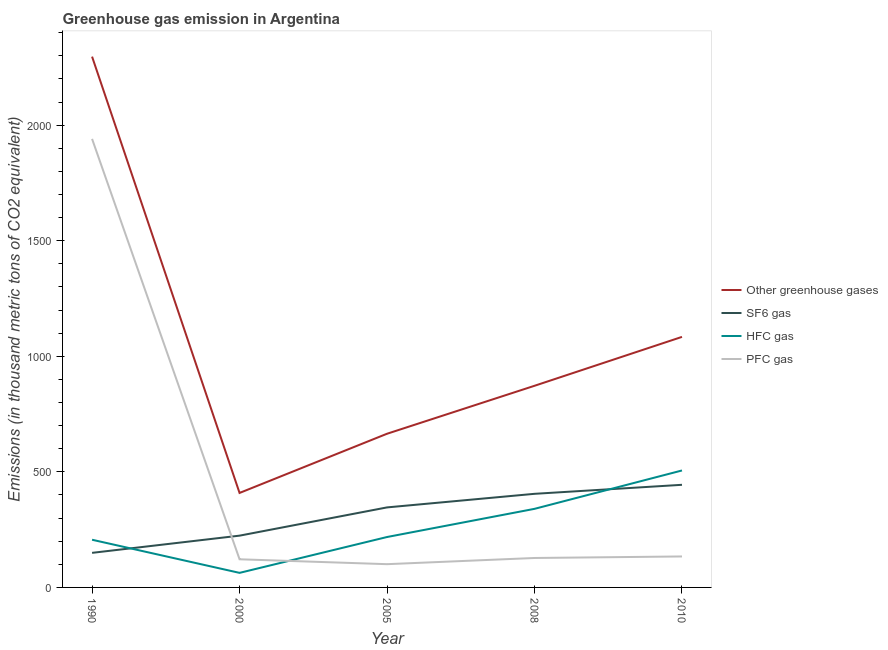How many different coloured lines are there?
Offer a very short reply. 4. What is the emission of hfc gas in 2005?
Make the answer very short. 218.1. Across all years, what is the maximum emission of sf6 gas?
Your response must be concise. 444. Across all years, what is the minimum emission of sf6 gas?
Your answer should be very brief. 149.6. What is the total emission of pfc gas in the graph?
Keep it short and to the point. 2424.4. What is the difference between the emission of sf6 gas in 1990 and that in 2008?
Ensure brevity in your answer.  -255.4. What is the difference between the emission of hfc gas in 2005 and the emission of sf6 gas in 2008?
Offer a terse response. -186.9. What is the average emission of hfc gas per year?
Ensure brevity in your answer.  266.68. In the year 2008, what is the difference between the emission of greenhouse gases and emission of hfc gas?
Your answer should be very brief. 532.4. In how many years, is the emission of hfc gas greater than 1200 thousand metric tons?
Your answer should be compact. 0. What is the ratio of the emission of hfc gas in 2000 to that in 2008?
Offer a very short reply. 0.19. Is the difference between the emission of sf6 gas in 1990 and 2005 greater than the difference between the emission of greenhouse gases in 1990 and 2005?
Your answer should be very brief. No. What is the difference between the highest and the second highest emission of pfc gas?
Give a very brief answer. 1806.6. What is the difference between the highest and the lowest emission of sf6 gas?
Provide a succinct answer. 294.4. In how many years, is the emission of pfc gas greater than the average emission of pfc gas taken over all years?
Your answer should be compact. 1. Is the sum of the emission of hfc gas in 2005 and 2010 greater than the maximum emission of pfc gas across all years?
Offer a terse response. No. Is it the case that in every year, the sum of the emission of greenhouse gases and emission of sf6 gas is greater than the emission of hfc gas?
Offer a terse response. Yes. Does the emission of pfc gas monotonically increase over the years?
Provide a succinct answer. No. Is the emission of greenhouse gases strictly less than the emission of hfc gas over the years?
Make the answer very short. No. How many years are there in the graph?
Your response must be concise. 5. What is the difference between two consecutive major ticks on the Y-axis?
Your response must be concise. 500. What is the title of the graph?
Ensure brevity in your answer.  Greenhouse gas emission in Argentina. Does "Secondary vocational" appear as one of the legend labels in the graph?
Keep it short and to the point. No. What is the label or title of the X-axis?
Your answer should be compact. Year. What is the label or title of the Y-axis?
Offer a terse response. Emissions (in thousand metric tons of CO2 equivalent). What is the Emissions (in thousand metric tons of CO2 equivalent) in Other greenhouse gases in 1990?
Make the answer very short. 2296.5. What is the Emissions (in thousand metric tons of CO2 equivalent) in SF6 gas in 1990?
Provide a succinct answer. 149.6. What is the Emissions (in thousand metric tons of CO2 equivalent) of HFC gas in 1990?
Your response must be concise. 206.3. What is the Emissions (in thousand metric tons of CO2 equivalent) in PFC gas in 1990?
Your answer should be very brief. 1940.6. What is the Emissions (in thousand metric tons of CO2 equivalent) of Other greenhouse gases in 2000?
Give a very brief answer. 408.8. What is the Emissions (in thousand metric tons of CO2 equivalent) of SF6 gas in 2000?
Your response must be concise. 224. What is the Emissions (in thousand metric tons of CO2 equivalent) of PFC gas in 2000?
Your answer should be very brief. 121.8. What is the Emissions (in thousand metric tons of CO2 equivalent) in Other greenhouse gases in 2005?
Your answer should be very brief. 664.9. What is the Emissions (in thousand metric tons of CO2 equivalent) of SF6 gas in 2005?
Keep it short and to the point. 346.2. What is the Emissions (in thousand metric tons of CO2 equivalent) of HFC gas in 2005?
Offer a terse response. 218.1. What is the Emissions (in thousand metric tons of CO2 equivalent) of PFC gas in 2005?
Offer a terse response. 100.6. What is the Emissions (in thousand metric tons of CO2 equivalent) in Other greenhouse gases in 2008?
Provide a short and direct response. 872.4. What is the Emissions (in thousand metric tons of CO2 equivalent) of SF6 gas in 2008?
Your answer should be compact. 405. What is the Emissions (in thousand metric tons of CO2 equivalent) in HFC gas in 2008?
Make the answer very short. 340. What is the Emissions (in thousand metric tons of CO2 equivalent) of PFC gas in 2008?
Your answer should be very brief. 127.4. What is the Emissions (in thousand metric tons of CO2 equivalent) of Other greenhouse gases in 2010?
Offer a terse response. 1084. What is the Emissions (in thousand metric tons of CO2 equivalent) of SF6 gas in 2010?
Offer a terse response. 444. What is the Emissions (in thousand metric tons of CO2 equivalent) of HFC gas in 2010?
Offer a very short reply. 506. What is the Emissions (in thousand metric tons of CO2 equivalent) in PFC gas in 2010?
Offer a terse response. 134. Across all years, what is the maximum Emissions (in thousand metric tons of CO2 equivalent) in Other greenhouse gases?
Offer a very short reply. 2296.5. Across all years, what is the maximum Emissions (in thousand metric tons of CO2 equivalent) in SF6 gas?
Make the answer very short. 444. Across all years, what is the maximum Emissions (in thousand metric tons of CO2 equivalent) in HFC gas?
Offer a terse response. 506. Across all years, what is the maximum Emissions (in thousand metric tons of CO2 equivalent) of PFC gas?
Your response must be concise. 1940.6. Across all years, what is the minimum Emissions (in thousand metric tons of CO2 equivalent) of Other greenhouse gases?
Ensure brevity in your answer.  408.8. Across all years, what is the minimum Emissions (in thousand metric tons of CO2 equivalent) of SF6 gas?
Keep it short and to the point. 149.6. Across all years, what is the minimum Emissions (in thousand metric tons of CO2 equivalent) in HFC gas?
Offer a terse response. 63. Across all years, what is the minimum Emissions (in thousand metric tons of CO2 equivalent) of PFC gas?
Provide a succinct answer. 100.6. What is the total Emissions (in thousand metric tons of CO2 equivalent) of Other greenhouse gases in the graph?
Offer a very short reply. 5326.6. What is the total Emissions (in thousand metric tons of CO2 equivalent) of SF6 gas in the graph?
Make the answer very short. 1568.8. What is the total Emissions (in thousand metric tons of CO2 equivalent) in HFC gas in the graph?
Your answer should be compact. 1333.4. What is the total Emissions (in thousand metric tons of CO2 equivalent) in PFC gas in the graph?
Your response must be concise. 2424.4. What is the difference between the Emissions (in thousand metric tons of CO2 equivalent) of Other greenhouse gases in 1990 and that in 2000?
Offer a terse response. 1887.7. What is the difference between the Emissions (in thousand metric tons of CO2 equivalent) of SF6 gas in 1990 and that in 2000?
Your answer should be very brief. -74.4. What is the difference between the Emissions (in thousand metric tons of CO2 equivalent) of HFC gas in 1990 and that in 2000?
Offer a terse response. 143.3. What is the difference between the Emissions (in thousand metric tons of CO2 equivalent) in PFC gas in 1990 and that in 2000?
Make the answer very short. 1818.8. What is the difference between the Emissions (in thousand metric tons of CO2 equivalent) in Other greenhouse gases in 1990 and that in 2005?
Ensure brevity in your answer.  1631.6. What is the difference between the Emissions (in thousand metric tons of CO2 equivalent) of SF6 gas in 1990 and that in 2005?
Provide a succinct answer. -196.6. What is the difference between the Emissions (in thousand metric tons of CO2 equivalent) in HFC gas in 1990 and that in 2005?
Make the answer very short. -11.8. What is the difference between the Emissions (in thousand metric tons of CO2 equivalent) in PFC gas in 1990 and that in 2005?
Keep it short and to the point. 1840. What is the difference between the Emissions (in thousand metric tons of CO2 equivalent) in Other greenhouse gases in 1990 and that in 2008?
Your response must be concise. 1424.1. What is the difference between the Emissions (in thousand metric tons of CO2 equivalent) in SF6 gas in 1990 and that in 2008?
Provide a short and direct response. -255.4. What is the difference between the Emissions (in thousand metric tons of CO2 equivalent) in HFC gas in 1990 and that in 2008?
Give a very brief answer. -133.7. What is the difference between the Emissions (in thousand metric tons of CO2 equivalent) in PFC gas in 1990 and that in 2008?
Your answer should be very brief. 1813.2. What is the difference between the Emissions (in thousand metric tons of CO2 equivalent) of Other greenhouse gases in 1990 and that in 2010?
Keep it short and to the point. 1212.5. What is the difference between the Emissions (in thousand metric tons of CO2 equivalent) of SF6 gas in 1990 and that in 2010?
Make the answer very short. -294.4. What is the difference between the Emissions (in thousand metric tons of CO2 equivalent) in HFC gas in 1990 and that in 2010?
Provide a short and direct response. -299.7. What is the difference between the Emissions (in thousand metric tons of CO2 equivalent) of PFC gas in 1990 and that in 2010?
Keep it short and to the point. 1806.6. What is the difference between the Emissions (in thousand metric tons of CO2 equivalent) in Other greenhouse gases in 2000 and that in 2005?
Keep it short and to the point. -256.1. What is the difference between the Emissions (in thousand metric tons of CO2 equivalent) of SF6 gas in 2000 and that in 2005?
Your answer should be very brief. -122.2. What is the difference between the Emissions (in thousand metric tons of CO2 equivalent) of HFC gas in 2000 and that in 2005?
Ensure brevity in your answer.  -155.1. What is the difference between the Emissions (in thousand metric tons of CO2 equivalent) in PFC gas in 2000 and that in 2005?
Provide a short and direct response. 21.2. What is the difference between the Emissions (in thousand metric tons of CO2 equivalent) in Other greenhouse gases in 2000 and that in 2008?
Give a very brief answer. -463.6. What is the difference between the Emissions (in thousand metric tons of CO2 equivalent) of SF6 gas in 2000 and that in 2008?
Offer a terse response. -181. What is the difference between the Emissions (in thousand metric tons of CO2 equivalent) in HFC gas in 2000 and that in 2008?
Offer a very short reply. -277. What is the difference between the Emissions (in thousand metric tons of CO2 equivalent) in PFC gas in 2000 and that in 2008?
Provide a short and direct response. -5.6. What is the difference between the Emissions (in thousand metric tons of CO2 equivalent) in Other greenhouse gases in 2000 and that in 2010?
Your answer should be very brief. -675.2. What is the difference between the Emissions (in thousand metric tons of CO2 equivalent) in SF6 gas in 2000 and that in 2010?
Offer a very short reply. -220. What is the difference between the Emissions (in thousand metric tons of CO2 equivalent) in HFC gas in 2000 and that in 2010?
Offer a terse response. -443. What is the difference between the Emissions (in thousand metric tons of CO2 equivalent) of Other greenhouse gases in 2005 and that in 2008?
Provide a succinct answer. -207.5. What is the difference between the Emissions (in thousand metric tons of CO2 equivalent) of SF6 gas in 2005 and that in 2008?
Keep it short and to the point. -58.8. What is the difference between the Emissions (in thousand metric tons of CO2 equivalent) in HFC gas in 2005 and that in 2008?
Your response must be concise. -121.9. What is the difference between the Emissions (in thousand metric tons of CO2 equivalent) of PFC gas in 2005 and that in 2008?
Provide a short and direct response. -26.8. What is the difference between the Emissions (in thousand metric tons of CO2 equivalent) of Other greenhouse gases in 2005 and that in 2010?
Provide a succinct answer. -419.1. What is the difference between the Emissions (in thousand metric tons of CO2 equivalent) in SF6 gas in 2005 and that in 2010?
Make the answer very short. -97.8. What is the difference between the Emissions (in thousand metric tons of CO2 equivalent) of HFC gas in 2005 and that in 2010?
Your answer should be very brief. -287.9. What is the difference between the Emissions (in thousand metric tons of CO2 equivalent) in PFC gas in 2005 and that in 2010?
Provide a short and direct response. -33.4. What is the difference between the Emissions (in thousand metric tons of CO2 equivalent) in Other greenhouse gases in 2008 and that in 2010?
Your answer should be very brief. -211.6. What is the difference between the Emissions (in thousand metric tons of CO2 equivalent) of SF6 gas in 2008 and that in 2010?
Offer a terse response. -39. What is the difference between the Emissions (in thousand metric tons of CO2 equivalent) of HFC gas in 2008 and that in 2010?
Ensure brevity in your answer.  -166. What is the difference between the Emissions (in thousand metric tons of CO2 equivalent) of PFC gas in 2008 and that in 2010?
Make the answer very short. -6.6. What is the difference between the Emissions (in thousand metric tons of CO2 equivalent) in Other greenhouse gases in 1990 and the Emissions (in thousand metric tons of CO2 equivalent) in SF6 gas in 2000?
Offer a terse response. 2072.5. What is the difference between the Emissions (in thousand metric tons of CO2 equivalent) of Other greenhouse gases in 1990 and the Emissions (in thousand metric tons of CO2 equivalent) of HFC gas in 2000?
Provide a succinct answer. 2233.5. What is the difference between the Emissions (in thousand metric tons of CO2 equivalent) in Other greenhouse gases in 1990 and the Emissions (in thousand metric tons of CO2 equivalent) in PFC gas in 2000?
Your response must be concise. 2174.7. What is the difference between the Emissions (in thousand metric tons of CO2 equivalent) of SF6 gas in 1990 and the Emissions (in thousand metric tons of CO2 equivalent) of HFC gas in 2000?
Provide a short and direct response. 86.6. What is the difference between the Emissions (in thousand metric tons of CO2 equivalent) in SF6 gas in 1990 and the Emissions (in thousand metric tons of CO2 equivalent) in PFC gas in 2000?
Your response must be concise. 27.8. What is the difference between the Emissions (in thousand metric tons of CO2 equivalent) of HFC gas in 1990 and the Emissions (in thousand metric tons of CO2 equivalent) of PFC gas in 2000?
Offer a terse response. 84.5. What is the difference between the Emissions (in thousand metric tons of CO2 equivalent) in Other greenhouse gases in 1990 and the Emissions (in thousand metric tons of CO2 equivalent) in SF6 gas in 2005?
Your answer should be very brief. 1950.3. What is the difference between the Emissions (in thousand metric tons of CO2 equivalent) of Other greenhouse gases in 1990 and the Emissions (in thousand metric tons of CO2 equivalent) of HFC gas in 2005?
Provide a succinct answer. 2078.4. What is the difference between the Emissions (in thousand metric tons of CO2 equivalent) of Other greenhouse gases in 1990 and the Emissions (in thousand metric tons of CO2 equivalent) of PFC gas in 2005?
Your answer should be compact. 2195.9. What is the difference between the Emissions (in thousand metric tons of CO2 equivalent) of SF6 gas in 1990 and the Emissions (in thousand metric tons of CO2 equivalent) of HFC gas in 2005?
Your response must be concise. -68.5. What is the difference between the Emissions (in thousand metric tons of CO2 equivalent) of HFC gas in 1990 and the Emissions (in thousand metric tons of CO2 equivalent) of PFC gas in 2005?
Provide a succinct answer. 105.7. What is the difference between the Emissions (in thousand metric tons of CO2 equivalent) in Other greenhouse gases in 1990 and the Emissions (in thousand metric tons of CO2 equivalent) in SF6 gas in 2008?
Offer a terse response. 1891.5. What is the difference between the Emissions (in thousand metric tons of CO2 equivalent) in Other greenhouse gases in 1990 and the Emissions (in thousand metric tons of CO2 equivalent) in HFC gas in 2008?
Provide a short and direct response. 1956.5. What is the difference between the Emissions (in thousand metric tons of CO2 equivalent) in Other greenhouse gases in 1990 and the Emissions (in thousand metric tons of CO2 equivalent) in PFC gas in 2008?
Keep it short and to the point. 2169.1. What is the difference between the Emissions (in thousand metric tons of CO2 equivalent) in SF6 gas in 1990 and the Emissions (in thousand metric tons of CO2 equivalent) in HFC gas in 2008?
Your answer should be compact. -190.4. What is the difference between the Emissions (in thousand metric tons of CO2 equivalent) of SF6 gas in 1990 and the Emissions (in thousand metric tons of CO2 equivalent) of PFC gas in 2008?
Make the answer very short. 22.2. What is the difference between the Emissions (in thousand metric tons of CO2 equivalent) of HFC gas in 1990 and the Emissions (in thousand metric tons of CO2 equivalent) of PFC gas in 2008?
Give a very brief answer. 78.9. What is the difference between the Emissions (in thousand metric tons of CO2 equivalent) in Other greenhouse gases in 1990 and the Emissions (in thousand metric tons of CO2 equivalent) in SF6 gas in 2010?
Make the answer very short. 1852.5. What is the difference between the Emissions (in thousand metric tons of CO2 equivalent) in Other greenhouse gases in 1990 and the Emissions (in thousand metric tons of CO2 equivalent) in HFC gas in 2010?
Offer a terse response. 1790.5. What is the difference between the Emissions (in thousand metric tons of CO2 equivalent) in Other greenhouse gases in 1990 and the Emissions (in thousand metric tons of CO2 equivalent) in PFC gas in 2010?
Your answer should be very brief. 2162.5. What is the difference between the Emissions (in thousand metric tons of CO2 equivalent) in SF6 gas in 1990 and the Emissions (in thousand metric tons of CO2 equivalent) in HFC gas in 2010?
Offer a very short reply. -356.4. What is the difference between the Emissions (in thousand metric tons of CO2 equivalent) of HFC gas in 1990 and the Emissions (in thousand metric tons of CO2 equivalent) of PFC gas in 2010?
Provide a succinct answer. 72.3. What is the difference between the Emissions (in thousand metric tons of CO2 equivalent) of Other greenhouse gases in 2000 and the Emissions (in thousand metric tons of CO2 equivalent) of SF6 gas in 2005?
Ensure brevity in your answer.  62.6. What is the difference between the Emissions (in thousand metric tons of CO2 equivalent) of Other greenhouse gases in 2000 and the Emissions (in thousand metric tons of CO2 equivalent) of HFC gas in 2005?
Give a very brief answer. 190.7. What is the difference between the Emissions (in thousand metric tons of CO2 equivalent) in Other greenhouse gases in 2000 and the Emissions (in thousand metric tons of CO2 equivalent) in PFC gas in 2005?
Provide a succinct answer. 308.2. What is the difference between the Emissions (in thousand metric tons of CO2 equivalent) of SF6 gas in 2000 and the Emissions (in thousand metric tons of CO2 equivalent) of HFC gas in 2005?
Keep it short and to the point. 5.9. What is the difference between the Emissions (in thousand metric tons of CO2 equivalent) in SF6 gas in 2000 and the Emissions (in thousand metric tons of CO2 equivalent) in PFC gas in 2005?
Offer a terse response. 123.4. What is the difference between the Emissions (in thousand metric tons of CO2 equivalent) in HFC gas in 2000 and the Emissions (in thousand metric tons of CO2 equivalent) in PFC gas in 2005?
Your answer should be compact. -37.6. What is the difference between the Emissions (in thousand metric tons of CO2 equivalent) of Other greenhouse gases in 2000 and the Emissions (in thousand metric tons of CO2 equivalent) of SF6 gas in 2008?
Make the answer very short. 3.8. What is the difference between the Emissions (in thousand metric tons of CO2 equivalent) of Other greenhouse gases in 2000 and the Emissions (in thousand metric tons of CO2 equivalent) of HFC gas in 2008?
Offer a very short reply. 68.8. What is the difference between the Emissions (in thousand metric tons of CO2 equivalent) in Other greenhouse gases in 2000 and the Emissions (in thousand metric tons of CO2 equivalent) in PFC gas in 2008?
Your answer should be very brief. 281.4. What is the difference between the Emissions (in thousand metric tons of CO2 equivalent) in SF6 gas in 2000 and the Emissions (in thousand metric tons of CO2 equivalent) in HFC gas in 2008?
Provide a short and direct response. -116. What is the difference between the Emissions (in thousand metric tons of CO2 equivalent) in SF6 gas in 2000 and the Emissions (in thousand metric tons of CO2 equivalent) in PFC gas in 2008?
Make the answer very short. 96.6. What is the difference between the Emissions (in thousand metric tons of CO2 equivalent) of HFC gas in 2000 and the Emissions (in thousand metric tons of CO2 equivalent) of PFC gas in 2008?
Offer a terse response. -64.4. What is the difference between the Emissions (in thousand metric tons of CO2 equivalent) in Other greenhouse gases in 2000 and the Emissions (in thousand metric tons of CO2 equivalent) in SF6 gas in 2010?
Your answer should be compact. -35.2. What is the difference between the Emissions (in thousand metric tons of CO2 equivalent) in Other greenhouse gases in 2000 and the Emissions (in thousand metric tons of CO2 equivalent) in HFC gas in 2010?
Give a very brief answer. -97.2. What is the difference between the Emissions (in thousand metric tons of CO2 equivalent) of Other greenhouse gases in 2000 and the Emissions (in thousand metric tons of CO2 equivalent) of PFC gas in 2010?
Ensure brevity in your answer.  274.8. What is the difference between the Emissions (in thousand metric tons of CO2 equivalent) of SF6 gas in 2000 and the Emissions (in thousand metric tons of CO2 equivalent) of HFC gas in 2010?
Keep it short and to the point. -282. What is the difference between the Emissions (in thousand metric tons of CO2 equivalent) of SF6 gas in 2000 and the Emissions (in thousand metric tons of CO2 equivalent) of PFC gas in 2010?
Provide a succinct answer. 90. What is the difference between the Emissions (in thousand metric tons of CO2 equivalent) of HFC gas in 2000 and the Emissions (in thousand metric tons of CO2 equivalent) of PFC gas in 2010?
Offer a terse response. -71. What is the difference between the Emissions (in thousand metric tons of CO2 equivalent) in Other greenhouse gases in 2005 and the Emissions (in thousand metric tons of CO2 equivalent) in SF6 gas in 2008?
Make the answer very short. 259.9. What is the difference between the Emissions (in thousand metric tons of CO2 equivalent) in Other greenhouse gases in 2005 and the Emissions (in thousand metric tons of CO2 equivalent) in HFC gas in 2008?
Your response must be concise. 324.9. What is the difference between the Emissions (in thousand metric tons of CO2 equivalent) in Other greenhouse gases in 2005 and the Emissions (in thousand metric tons of CO2 equivalent) in PFC gas in 2008?
Ensure brevity in your answer.  537.5. What is the difference between the Emissions (in thousand metric tons of CO2 equivalent) in SF6 gas in 2005 and the Emissions (in thousand metric tons of CO2 equivalent) in PFC gas in 2008?
Offer a terse response. 218.8. What is the difference between the Emissions (in thousand metric tons of CO2 equivalent) of HFC gas in 2005 and the Emissions (in thousand metric tons of CO2 equivalent) of PFC gas in 2008?
Keep it short and to the point. 90.7. What is the difference between the Emissions (in thousand metric tons of CO2 equivalent) in Other greenhouse gases in 2005 and the Emissions (in thousand metric tons of CO2 equivalent) in SF6 gas in 2010?
Offer a terse response. 220.9. What is the difference between the Emissions (in thousand metric tons of CO2 equivalent) of Other greenhouse gases in 2005 and the Emissions (in thousand metric tons of CO2 equivalent) of HFC gas in 2010?
Provide a succinct answer. 158.9. What is the difference between the Emissions (in thousand metric tons of CO2 equivalent) of Other greenhouse gases in 2005 and the Emissions (in thousand metric tons of CO2 equivalent) of PFC gas in 2010?
Ensure brevity in your answer.  530.9. What is the difference between the Emissions (in thousand metric tons of CO2 equivalent) of SF6 gas in 2005 and the Emissions (in thousand metric tons of CO2 equivalent) of HFC gas in 2010?
Ensure brevity in your answer.  -159.8. What is the difference between the Emissions (in thousand metric tons of CO2 equivalent) in SF6 gas in 2005 and the Emissions (in thousand metric tons of CO2 equivalent) in PFC gas in 2010?
Give a very brief answer. 212.2. What is the difference between the Emissions (in thousand metric tons of CO2 equivalent) in HFC gas in 2005 and the Emissions (in thousand metric tons of CO2 equivalent) in PFC gas in 2010?
Give a very brief answer. 84.1. What is the difference between the Emissions (in thousand metric tons of CO2 equivalent) in Other greenhouse gases in 2008 and the Emissions (in thousand metric tons of CO2 equivalent) in SF6 gas in 2010?
Offer a terse response. 428.4. What is the difference between the Emissions (in thousand metric tons of CO2 equivalent) in Other greenhouse gases in 2008 and the Emissions (in thousand metric tons of CO2 equivalent) in HFC gas in 2010?
Offer a very short reply. 366.4. What is the difference between the Emissions (in thousand metric tons of CO2 equivalent) in Other greenhouse gases in 2008 and the Emissions (in thousand metric tons of CO2 equivalent) in PFC gas in 2010?
Offer a very short reply. 738.4. What is the difference between the Emissions (in thousand metric tons of CO2 equivalent) of SF6 gas in 2008 and the Emissions (in thousand metric tons of CO2 equivalent) of HFC gas in 2010?
Your answer should be compact. -101. What is the difference between the Emissions (in thousand metric tons of CO2 equivalent) in SF6 gas in 2008 and the Emissions (in thousand metric tons of CO2 equivalent) in PFC gas in 2010?
Give a very brief answer. 271. What is the difference between the Emissions (in thousand metric tons of CO2 equivalent) of HFC gas in 2008 and the Emissions (in thousand metric tons of CO2 equivalent) of PFC gas in 2010?
Your answer should be compact. 206. What is the average Emissions (in thousand metric tons of CO2 equivalent) of Other greenhouse gases per year?
Your answer should be very brief. 1065.32. What is the average Emissions (in thousand metric tons of CO2 equivalent) of SF6 gas per year?
Keep it short and to the point. 313.76. What is the average Emissions (in thousand metric tons of CO2 equivalent) in HFC gas per year?
Make the answer very short. 266.68. What is the average Emissions (in thousand metric tons of CO2 equivalent) in PFC gas per year?
Your response must be concise. 484.88. In the year 1990, what is the difference between the Emissions (in thousand metric tons of CO2 equivalent) in Other greenhouse gases and Emissions (in thousand metric tons of CO2 equivalent) in SF6 gas?
Make the answer very short. 2146.9. In the year 1990, what is the difference between the Emissions (in thousand metric tons of CO2 equivalent) of Other greenhouse gases and Emissions (in thousand metric tons of CO2 equivalent) of HFC gas?
Make the answer very short. 2090.2. In the year 1990, what is the difference between the Emissions (in thousand metric tons of CO2 equivalent) in Other greenhouse gases and Emissions (in thousand metric tons of CO2 equivalent) in PFC gas?
Make the answer very short. 355.9. In the year 1990, what is the difference between the Emissions (in thousand metric tons of CO2 equivalent) of SF6 gas and Emissions (in thousand metric tons of CO2 equivalent) of HFC gas?
Your response must be concise. -56.7. In the year 1990, what is the difference between the Emissions (in thousand metric tons of CO2 equivalent) in SF6 gas and Emissions (in thousand metric tons of CO2 equivalent) in PFC gas?
Ensure brevity in your answer.  -1791. In the year 1990, what is the difference between the Emissions (in thousand metric tons of CO2 equivalent) in HFC gas and Emissions (in thousand metric tons of CO2 equivalent) in PFC gas?
Provide a short and direct response. -1734.3. In the year 2000, what is the difference between the Emissions (in thousand metric tons of CO2 equivalent) of Other greenhouse gases and Emissions (in thousand metric tons of CO2 equivalent) of SF6 gas?
Ensure brevity in your answer.  184.8. In the year 2000, what is the difference between the Emissions (in thousand metric tons of CO2 equivalent) in Other greenhouse gases and Emissions (in thousand metric tons of CO2 equivalent) in HFC gas?
Make the answer very short. 345.8. In the year 2000, what is the difference between the Emissions (in thousand metric tons of CO2 equivalent) of Other greenhouse gases and Emissions (in thousand metric tons of CO2 equivalent) of PFC gas?
Offer a terse response. 287. In the year 2000, what is the difference between the Emissions (in thousand metric tons of CO2 equivalent) in SF6 gas and Emissions (in thousand metric tons of CO2 equivalent) in HFC gas?
Provide a short and direct response. 161. In the year 2000, what is the difference between the Emissions (in thousand metric tons of CO2 equivalent) in SF6 gas and Emissions (in thousand metric tons of CO2 equivalent) in PFC gas?
Your answer should be very brief. 102.2. In the year 2000, what is the difference between the Emissions (in thousand metric tons of CO2 equivalent) in HFC gas and Emissions (in thousand metric tons of CO2 equivalent) in PFC gas?
Make the answer very short. -58.8. In the year 2005, what is the difference between the Emissions (in thousand metric tons of CO2 equivalent) in Other greenhouse gases and Emissions (in thousand metric tons of CO2 equivalent) in SF6 gas?
Offer a terse response. 318.7. In the year 2005, what is the difference between the Emissions (in thousand metric tons of CO2 equivalent) of Other greenhouse gases and Emissions (in thousand metric tons of CO2 equivalent) of HFC gas?
Make the answer very short. 446.8. In the year 2005, what is the difference between the Emissions (in thousand metric tons of CO2 equivalent) in Other greenhouse gases and Emissions (in thousand metric tons of CO2 equivalent) in PFC gas?
Provide a short and direct response. 564.3. In the year 2005, what is the difference between the Emissions (in thousand metric tons of CO2 equivalent) of SF6 gas and Emissions (in thousand metric tons of CO2 equivalent) of HFC gas?
Provide a succinct answer. 128.1. In the year 2005, what is the difference between the Emissions (in thousand metric tons of CO2 equivalent) in SF6 gas and Emissions (in thousand metric tons of CO2 equivalent) in PFC gas?
Make the answer very short. 245.6. In the year 2005, what is the difference between the Emissions (in thousand metric tons of CO2 equivalent) in HFC gas and Emissions (in thousand metric tons of CO2 equivalent) in PFC gas?
Give a very brief answer. 117.5. In the year 2008, what is the difference between the Emissions (in thousand metric tons of CO2 equivalent) in Other greenhouse gases and Emissions (in thousand metric tons of CO2 equivalent) in SF6 gas?
Provide a short and direct response. 467.4. In the year 2008, what is the difference between the Emissions (in thousand metric tons of CO2 equivalent) of Other greenhouse gases and Emissions (in thousand metric tons of CO2 equivalent) of HFC gas?
Ensure brevity in your answer.  532.4. In the year 2008, what is the difference between the Emissions (in thousand metric tons of CO2 equivalent) in Other greenhouse gases and Emissions (in thousand metric tons of CO2 equivalent) in PFC gas?
Make the answer very short. 745. In the year 2008, what is the difference between the Emissions (in thousand metric tons of CO2 equivalent) in SF6 gas and Emissions (in thousand metric tons of CO2 equivalent) in PFC gas?
Your response must be concise. 277.6. In the year 2008, what is the difference between the Emissions (in thousand metric tons of CO2 equivalent) of HFC gas and Emissions (in thousand metric tons of CO2 equivalent) of PFC gas?
Your answer should be compact. 212.6. In the year 2010, what is the difference between the Emissions (in thousand metric tons of CO2 equivalent) in Other greenhouse gases and Emissions (in thousand metric tons of CO2 equivalent) in SF6 gas?
Provide a succinct answer. 640. In the year 2010, what is the difference between the Emissions (in thousand metric tons of CO2 equivalent) in Other greenhouse gases and Emissions (in thousand metric tons of CO2 equivalent) in HFC gas?
Your answer should be compact. 578. In the year 2010, what is the difference between the Emissions (in thousand metric tons of CO2 equivalent) of Other greenhouse gases and Emissions (in thousand metric tons of CO2 equivalent) of PFC gas?
Provide a short and direct response. 950. In the year 2010, what is the difference between the Emissions (in thousand metric tons of CO2 equivalent) of SF6 gas and Emissions (in thousand metric tons of CO2 equivalent) of HFC gas?
Your answer should be compact. -62. In the year 2010, what is the difference between the Emissions (in thousand metric tons of CO2 equivalent) in SF6 gas and Emissions (in thousand metric tons of CO2 equivalent) in PFC gas?
Provide a short and direct response. 310. In the year 2010, what is the difference between the Emissions (in thousand metric tons of CO2 equivalent) in HFC gas and Emissions (in thousand metric tons of CO2 equivalent) in PFC gas?
Provide a short and direct response. 372. What is the ratio of the Emissions (in thousand metric tons of CO2 equivalent) of Other greenhouse gases in 1990 to that in 2000?
Your answer should be very brief. 5.62. What is the ratio of the Emissions (in thousand metric tons of CO2 equivalent) in SF6 gas in 1990 to that in 2000?
Make the answer very short. 0.67. What is the ratio of the Emissions (in thousand metric tons of CO2 equivalent) of HFC gas in 1990 to that in 2000?
Your response must be concise. 3.27. What is the ratio of the Emissions (in thousand metric tons of CO2 equivalent) of PFC gas in 1990 to that in 2000?
Offer a terse response. 15.93. What is the ratio of the Emissions (in thousand metric tons of CO2 equivalent) in Other greenhouse gases in 1990 to that in 2005?
Keep it short and to the point. 3.45. What is the ratio of the Emissions (in thousand metric tons of CO2 equivalent) of SF6 gas in 1990 to that in 2005?
Ensure brevity in your answer.  0.43. What is the ratio of the Emissions (in thousand metric tons of CO2 equivalent) in HFC gas in 1990 to that in 2005?
Keep it short and to the point. 0.95. What is the ratio of the Emissions (in thousand metric tons of CO2 equivalent) of PFC gas in 1990 to that in 2005?
Your answer should be very brief. 19.29. What is the ratio of the Emissions (in thousand metric tons of CO2 equivalent) of Other greenhouse gases in 1990 to that in 2008?
Your answer should be very brief. 2.63. What is the ratio of the Emissions (in thousand metric tons of CO2 equivalent) of SF6 gas in 1990 to that in 2008?
Provide a succinct answer. 0.37. What is the ratio of the Emissions (in thousand metric tons of CO2 equivalent) in HFC gas in 1990 to that in 2008?
Offer a very short reply. 0.61. What is the ratio of the Emissions (in thousand metric tons of CO2 equivalent) in PFC gas in 1990 to that in 2008?
Offer a very short reply. 15.23. What is the ratio of the Emissions (in thousand metric tons of CO2 equivalent) in Other greenhouse gases in 1990 to that in 2010?
Offer a terse response. 2.12. What is the ratio of the Emissions (in thousand metric tons of CO2 equivalent) of SF6 gas in 1990 to that in 2010?
Make the answer very short. 0.34. What is the ratio of the Emissions (in thousand metric tons of CO2 equivalent) of HFC gas in 1990 to that in 2010?
Your answer should be very brief. 0.41. What is the ratio of the Emissions (in thousand metric tons of CO2 equivalent) of PFC gas in 1990 to that in 2010?
Keep it short and to the point. 14.48. What is the ratio of the Emissions (in thousand metric tons of CO2 equivalent) in Other greenhouse gases in 2000 to that in 2005?
Keep it short and to the point. 0.61. What is the ratio of the Emissions (in thousand metric tons of CO2 equivalent) of SF6 gas in 2000 to that in 2005?
Give a very brief answer. 0.65. What is the ratio of the Emissions (in thousand metric tons of CO2 equivalent) of HFC gas in 2000 to that in 2005?
Provide a succinct answer. 0.29. What is the ratio of the Emissions (in thousand metric tons of CO2 equivalent) in PFC gas in 2000 to that in 2005?
Your answer should be very brief. 1.21. What is the ratio of the Emissions (in thousand metric tons of CO2 equivalent) of Other greenhouse gases in 2000 to that in 2008?
Provide a succinct answer. 0.47. What is the ratio of the Emissions (in thousand metric tons of CO2 equivalent) of SF6 gas in 2000 to that in 2008?
Give a very brief answer. 0.55. What is the ratio of the Emissions (in thousand metric tons of CO2 equivalent) of HFC gas in 2000 to that in 2008?
Keep it short and to the point. 0.19. What is the ratio of the Emissions (in thousand metric tons of CO2 equivalent) of PFC gas in 2000 to that in 2008?
Give a very brief answer. 0.96. What is the ratio of the Emissions (in thousand metric tons of CO2 equivalent) of Other greenhouse gases in 2000 to that in 2010?
Make the answer very short. 0.38. What is the ratio of the Emissions (in thousand metric tons of CO2 equivalent) of SF6 gas in 2000 to that in 2010?
Provide a short and direct response. 0.5. What is the ratio of the Emissions (in thousand metric tons of CO2 equivalent) of HFC gas in 2000 to that in 2010?
Give a very brief answer. 0.12. What is the ratio of the Emissions (in thousand metric tons of CO2 equivalent) in PFC gas in 2000 to that in 2010?
Give a very brief answer. 0.91. What is the ratio of the Emissions (in thousand metric tons of CO2 equivalent) of Other greenhouse gases in 2005 to that in 2008?
Offer a very short reply. 0.76. What is the ratio of the Emissions (in thousand metric tons of CO2 equivalent) of SF6 gas in 2005 to that in 2008?
Provide a succinct answer. 0.85. What is the ratio of the Emissions (in thousand metric tons of CO2 equivalent) in HFC gas in 2005 to that in 2008?
Offer a terse response. 0.64. What is the ratio of the Emissions (in thousand metric tons of CO2 equivalent) in PFC gas in 2005 to that in 2008?
Provide a short and direct response. 0.79. What is the ratio of the Emissions (in thousand metric tons of CO2 equivalent) of Other greenhouse gases in 2005 to that in 2010?
Give a very brief answer. 0.61. What is the ratio of the Emissions (in thousand metric tons of CO2 equivalent) in SF6 gas in 2005 to that in 2010?
Give a very brief answer. 0.78. What is the ratio of the Emissions (in thousand metric tons of CO2 equivalent) in HFC gas in 2005 to that in 2010?
Your response must be concise. 0.43. What is the ratio of the Emissions (in thousand metric tons of CO2 equivalent) of PFC gas in 2005 to that in 2010?
Keep it short and to the point. 0.75. What is the ratio of the Emissions (in thousand metric tons of CO2 equivalent) of Other greenhouse gases in 2008 to that in 2010?
Your answer should be very brief. 0.8. What is the ratio of the Emissions (in thousand metric tons of CO2 equivalent) in SF6 gas in 2008 to that in 2010?
Your response must be concise. 0.91. What is the ratio of the Emissions (in thousand metric tons of CO2 equivalent) in HFC gas in 2008 to that in 2010?
Offer a terse response. 0.67. What is the ratio of the Emissions (in thousand metric tons of CO2 equivalent) in PFC gas in 2008 to that in 2010?
Offer a very short reply. 0.95. What is the difference between the highest and the second highest Emissions (in thousand metric tons of CO2 equivalent) in Other greenhouse gases?
Make the answer very short. 1212.5. What is the difference between the highest and the second highest Emissions (in thousand metric tons of CO2 equivalent) of SF6 gas?
Ensure brevity in your answer.  39. What is the difference between the highest and the second highest Emissions (in thousand metric tons of CO2 equivalent) in HFC gas?
Make the answer very short. 166. What is the difference between the highest and the second highest Emissions (in thousand metric tons of CO2 equivalent) of PFC gas?
Give a very brief answer. 1806.6. What is the difference between the highest and the lowest Emissions (in thousand metric tons of CO2 equivalent) of Other greenhouse gases?
Provide a short and direct response. 1887.7. What is the difference between the highest and the lowest Emissions (in thousand metric tons of CO2 equivalent) of SF6 gas?
Provide a succinct answer. 294.4. What is the difference between the highest and the lowest Emissions (in thousand metric tons of CO2 equivalent) in HFC gas?
Provide a short and direct response. 443. What is the difference between the highest and the lowest Emissions (in thousand metric tons of CO2 equivalent) of PFC gas?
Your answer should be compact. 1840. 